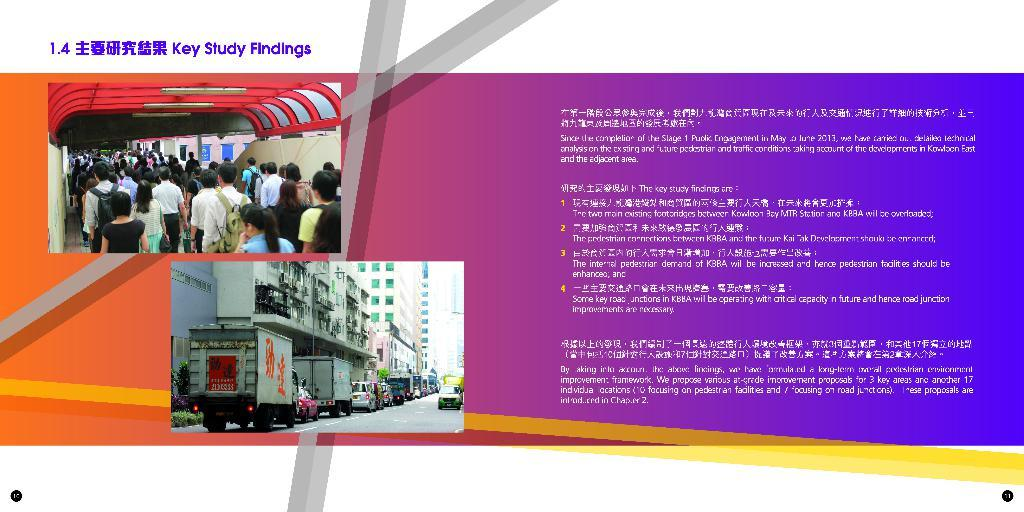What is the main subject of the poster in the image? The poster contains images of people, vehicles on the road, and buildings. What type of information is present on the poster? The poster contains some information. What rhythm does the jelly have in the image? There is no jelly present in the image, so it cannot have a rhythm. 